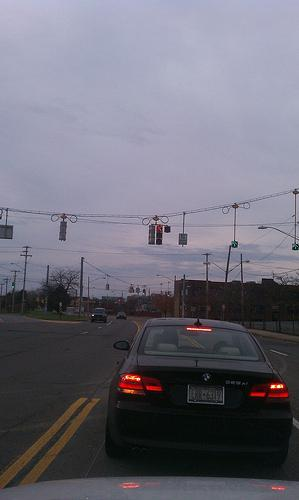Question: what are the bright lights in the rear?
Choices:
A. Christmas lights.
B. Rear lights.
C. Break lights.
D. Decorative lights.
Answer with the letter. Answer: C Question: where is the traffic light?
Choices:
A. To the left.
B. To the right.
C. Overhead.
D. On the ground.
Answer with the letter. Answer: C Question: who must stop?
Choices:
A. Pedestrians.
B. Travelers.
C. Truck drivers.
D. All cars going towards the red.
Answer with the letter. Answer: D Question: why have traffic lights?
Choices:
A. For safety.
B. So drivers know when to stop.
C. So drivers know when to go.
D. Flow control.
Answer with the letter. Answer: D 